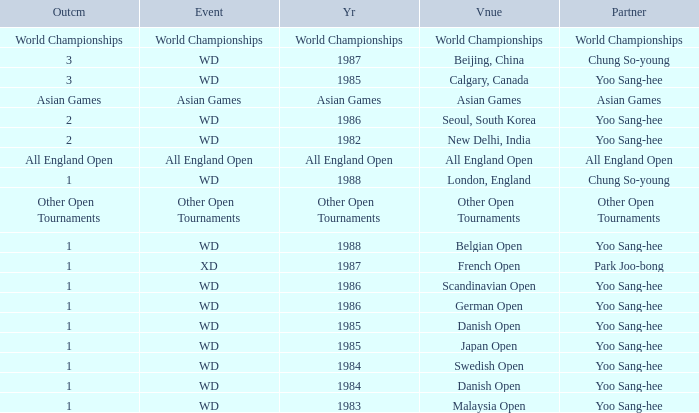What is the Partner during the Asian Games Year? Asian Games. 